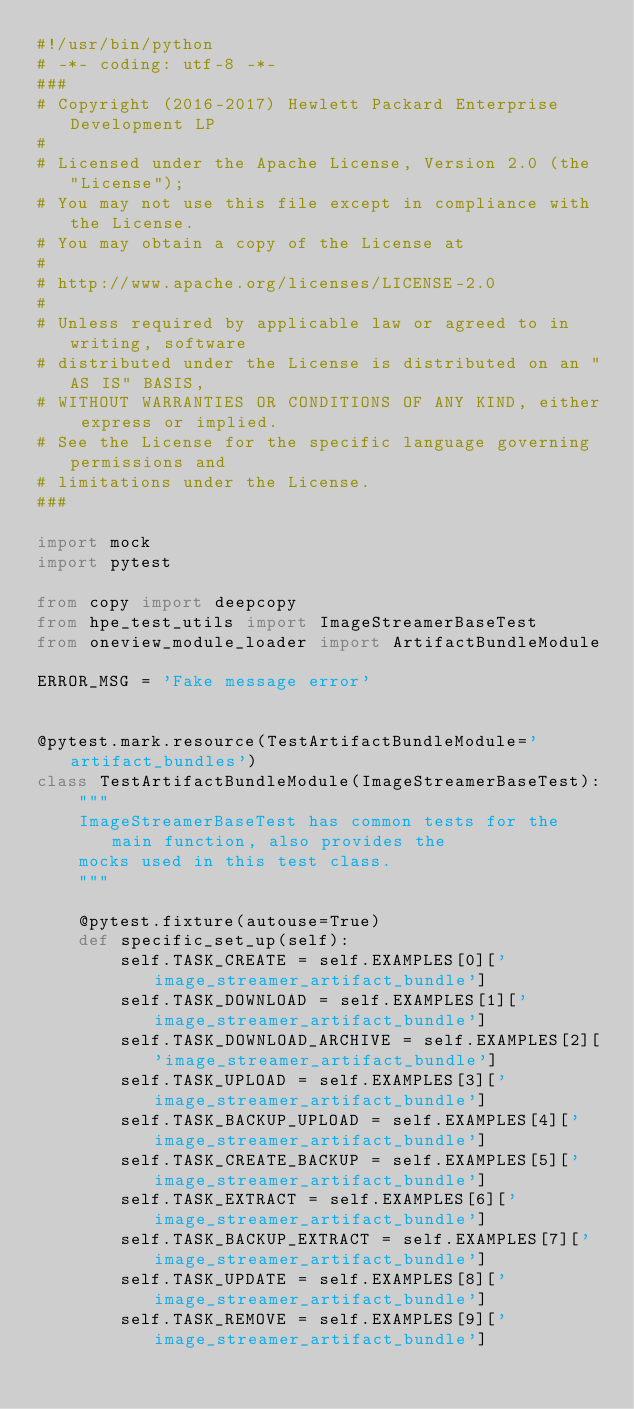Convert code to text. <code><loc_0><loc_0><loc_500><loc_500><_Python_>#!/usr/bin/python
# -*- coding: utf-8 -*-
###
# Copyright (2016-2017) Hewlett Packard Enterprise Development LP
#
# Licensed under the Apache License, Version 2.0 (the "License");
# You may not use this file except in compliance with the License.
# You may obtain a copy of the License at
#
# http://www.apache.org/licenses/LICENSE-2.0
#
# Unless required by applicable law or agreed to in writing, software
# distributed under the License is distributed on an "AS IS" BASIS,
# WITHOUT WARRANTIES OR CONDITIONS OF ANY KIND, either express or implied.
# See the License for the specific language governing permissions and
# limitations under the License.
###

import mock
import pytest

from copy import deepcopy
from hpe_test_utils import ImageStreamerBaseTest
from oneview_module_loader import ArtifactBundleModule

ERROR_MSG = 'Fake message error'


@pytest.mark.resource(TestArtifactBundleModule='artifact_bundles')
class TestArtifactBundleModule(ImageStreamerBaseTest):
    """
    ImageStreamerBaseTest has common tests for the main function, also provides the
    mocks used in this test class.
    """

    @pytest.fixture(autouse=True)
    def specific_set_up(self):
        self.TASK_CREATE = self.EXAMPLES[0]['image_streamer_artifact_bundle']
        self.TASK_DOWNLOAD = self.EXAMPLES[1]['image_streamer_artifact_bundle']
        self.TASK_DOWNLOAD_ARCHIVE = self.EXAMPLES[2]['image_streamer_artifact_bundle']
        self.TASK_UPLOAD = self.EXAMPLES[3]['image_streamer_artifact_bundle']
        self.TASK_BACKUP_UPLOAD = self.EXAMPLES[4]['image_streamer_artifact_bundle']
        self.TASK_CREATE_BACKUP = self.EXAMPLES[5]['image_streamer_artifact_bundle']
        self.TASK_EXTRACT = self.EXAMPLES[6]['image_streamer_artifact_bundle']
        self.TASK_BACKUP_EXTRACT = self.EXAMPLES[7]['image_streamer_artifact_bundle']
        self.TASK_UPDATE = self.EXAMPLES[8]['image_streamer_artifact_bundle']
        self.TASK_REMOVE = self.EXAMPLES[9]['image_streamer_artifact_bundle']
</code> 